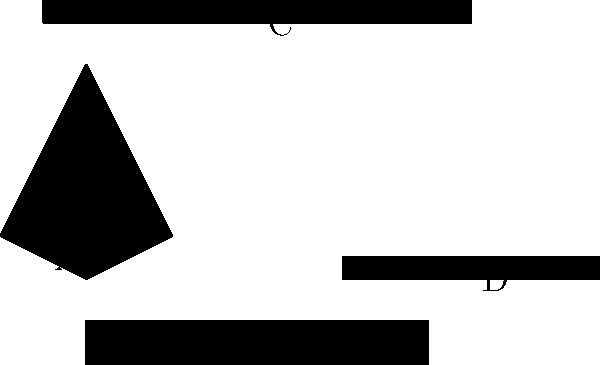Identify the traditional Aboriginal Australian hunting tool represented by silhouette A in the image above. To identify the traditional Aboriginal Australian hunting tool represented by silhouette A, let's analyze the shapes and their cultural context:

1. Silhouette A shows a curved, V-shaped object with uneven arms. This distinctive shape is characteristic of a boomerang.

2. Boomerangs are iconic tools associated with Aboriginal Australian culture, used for hunting and sometimes as recreational objects.

3. The other silhouettes represent:
   B: A didgeridoo, a wind instrument
   C: A blowgun, used by various indigenous cultures but not typically associated with Aboriginal Australians
   D: A throwing stick or club

4. Among these options, the boomerang is the most recognizable and culturally significant hunting tool for Aboriginal Australians.

5. Boomerangs were used for hunting small game and birds. The curved design allows it to return to the thrower when thrown correctly, making it an efficient hunting tool.

6. The asymmetrical shape of silhouette A matches the aerodynamic design of a non-returning boomerang, which was more commonly used for hunting than its returning counterpart.

Given these characteristics and cultural context, silhouette A clearly represents a boomerang, a traditional Aboriginal Australian hunting tool.
Answer: Boomerang 